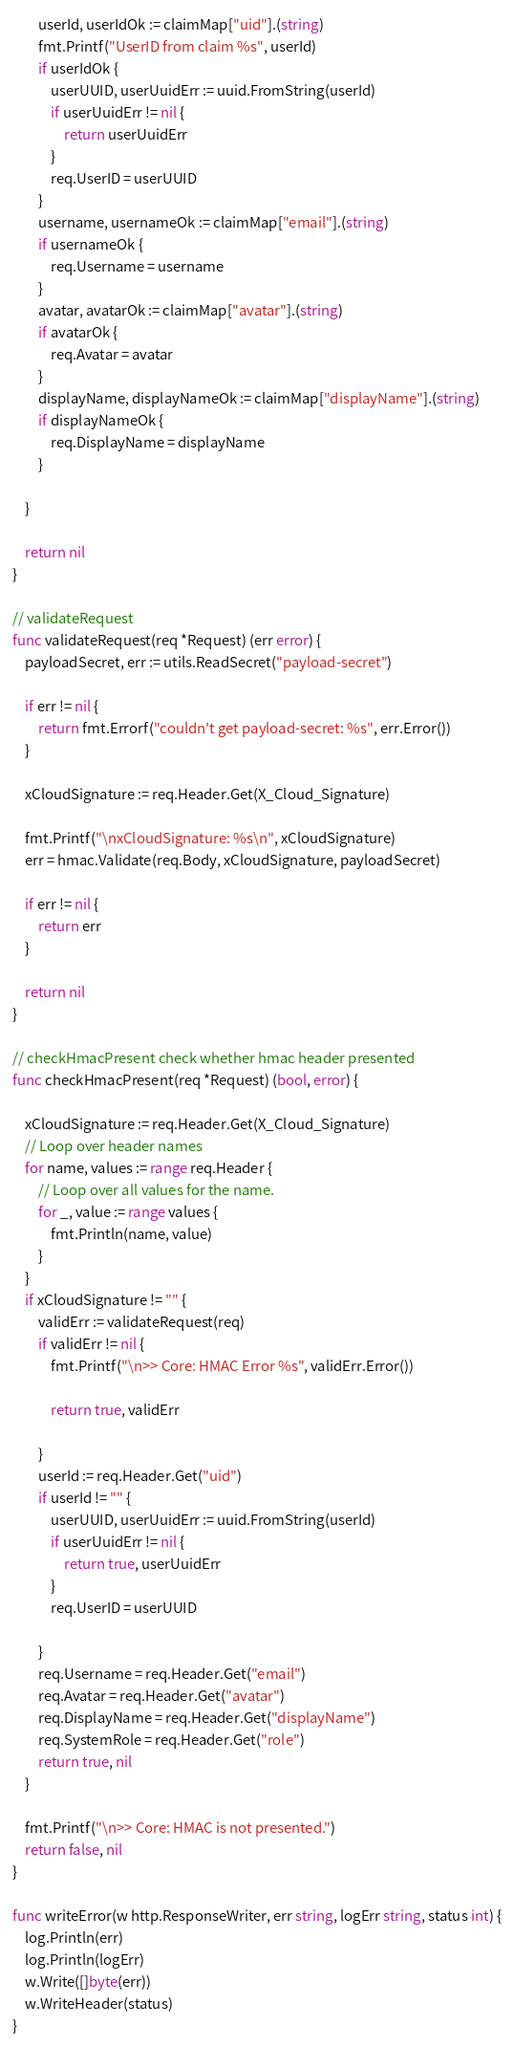Convert code to text. <code><loc_0><loc_0><loc_500><loc_500><_Go_>		userId, userIdOk := claimMap["uid"].(string)
		fmt.Printf("UserID from claim %s", userId)
		if userIdOk {
			userUUID, userUuidErr := uuid.FromString(userId)
			if userUuidErr != nil {
				return userUuidErr
			}
			req.UserID = userUUID
		}
		username, usernameOk := claimMap["email"].(string)
		if usernameOk {
			req.Username = username
		}
		avatar, avatarOk := claimMap["avatar"].(string)
		if avatarOk {
			req.Avatar = avatar
		}
		displayName, displayNameOk := claimMap["displayName"].(string)
		if displayNameOk {
			req.DisplayName = displayName
		}

	}

	return nil
}

// validateRequest
func validateRequest(req *Request) (err error) {
	payloadSecret, err := utils.ReadSecret("payload-secret")

	if err != nil {
		return fmt.Errorf("couldn't get payload-secret: %s", err.Error())
	}

	xCloudSignature := req.Header.Get(X_Cloud_Signature)

	fmt.Printf("\nxCloudSignature: %s\n", xCloudSignature)
	err = hmac.Validate(req.Body, xCloudSignature, payloadSecret)

	if err != nil {
		return err
	}

	return nil
}

// checkHmacPresent check whether hmac header presented
func checkHmacPresent(req *Request) (bool, error) {

	xCloudSignature := req.Header.Get(X_Cloud_Signature)
	// Loop over header names
	for name, values := range req.Header {
		// Loop over all values for the name.
		for _, value := range values {
			fmt.Println(name, value)
		}
	}
	if xCloudSignature != "" {
		validErr := validateRequest(req)
		if validErr != nil {
			fmt.Printf("\n>> Core: HMAC Error %s", validErr.Error())

			return true, validErr

		}
		userId := req.Header.Get("uid")
		if userId != "" {
			userUUID, userUuidErr := uuid.FromString(userId)
			if userUuidErr != nil {
				return true, userUuidErr
			}
			req.UserID = userUUID

		}
		req.Username = req.Header.Get("email")
		req.Avatar = req.Header.Get("avatar")
		req.DisplayName = req.Header.Get("displayName")
		req.SystemRole = req.Header.Get("role")
		return true, nil
	}

	fmt.Printf("\n>> Core: HMAC is not presented.")
	return false, nil
}

func writeError(w http.ResponseWriter, err string, logErr string, status int) {
	log.Println(err)
	log.Println(logErr)
	w.Write([]byte(err))
	w.WriteHeader(status)
}
</code> 